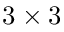Convert formula to latex. <formula><loc_0><loc_0><loc_500><loc_500>3 \times 3</formula> 